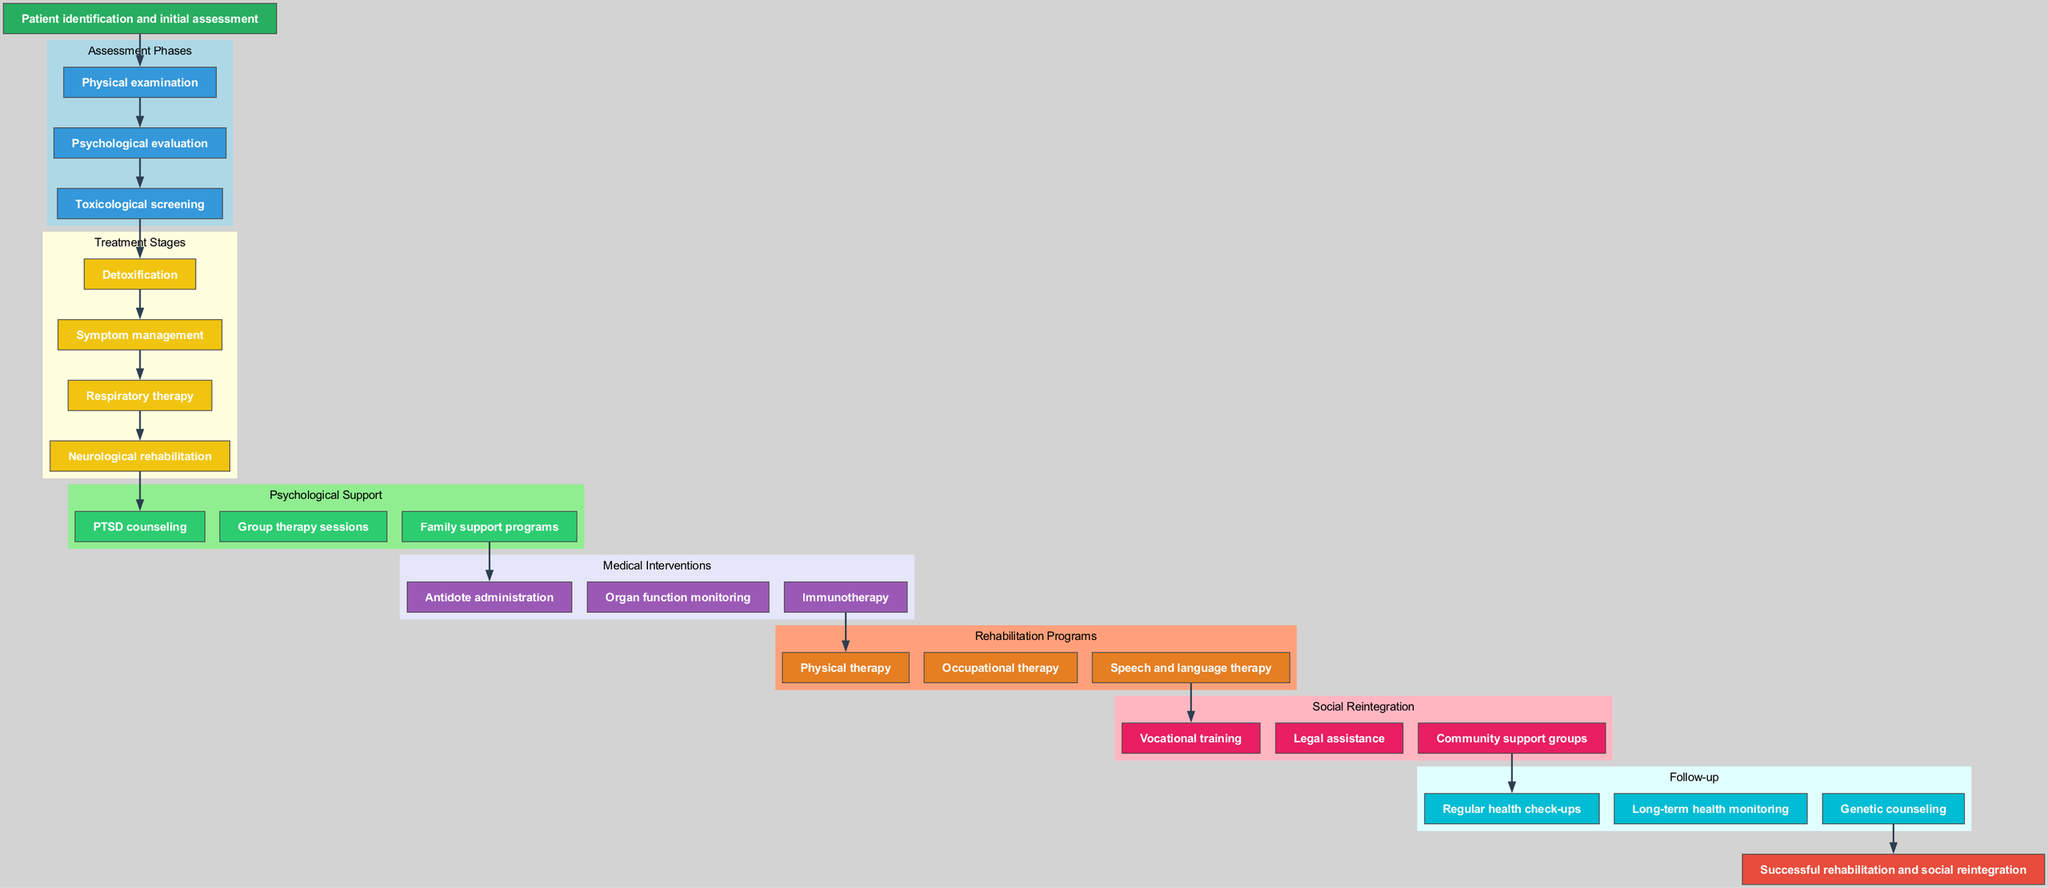What is the starting point of the clinical pathway? The starting point is explicitly noted as "Patient identification and initial assessment" in the diagram, indicating the first step in the clinical pathway.
Answer: Patient identification and initial assessment How many assessment phases are there? The diagram lists three assessment phases: physical examination, psychological evaluation, and toxicological screening. Counting these phases gives a total of three.
Answer: 3 What is the last treatment stage before psychological support? The treatment stages listed end with "Neurological rehabilitation." This is the stage that precedes the psychological support phase in the diagram.
Answer: Neurological rehabilitation Which node connects the treatment stages to the psychological support phase? The edge in the diagram connects "Symptom management" to the first psychological support node, indicating the transition from treatment to psychological support.
Answer: Symptom management What are the main components of rehabilitation programs? The rehabilitation programs listed in the diagram include physical therapy, occupational therapy, and speech and language therapy. Therefore, these form the core components of the rehabilitation phase.
Answer: Physical therapy, Occupational therapy, Speech and language therapy How do the social reintegration and follow-up phases relate to each other? The diagram shows that after completing the social reintegration phase, which encompasses vocational training, legal assistance, and community support groups, the pathway flows into the follow-up phase. This establishes a direct connection between them.
Answer: Direct connection What type of interventions are included under medical interventions? The diagram specifies antidote administration, organ function monitoring, and immunotherapy as part of medical interventions, which are crucial for victims of chemical exposure.
Answer: Antidote administration, Organ function monitoring, Immunotherapy What is the endpoint of the clinical pathway? The endpoint of the pathway is clearly defined as "Successful rehabilitation and social reintegration," which summarizes the goal of the entire pathway.
Answer: Successful rehabilitation and social reintegration Which phase follows the psychological support stage? Based on the flow in the diagram, after psychological support, the next phase is medical interventions, indicating a sequential process in the treatment of the patients.
Answer: Medical interventions 